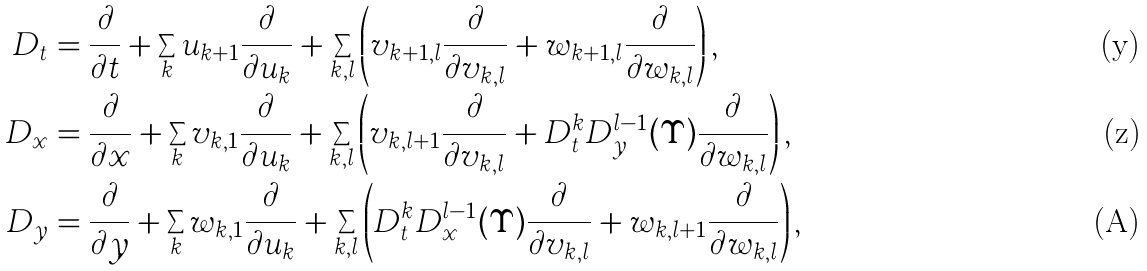Convert formula to latex. <formula><loc_0><loc_0><loc_500><loc_500>D _ { t } & = \frac { \partial } { \partial t } + \sum _ { k } u _ { k + 1 } \frac { \partial } { \partial u _ { k } } + \sum _ { k , l } \left ( v _ { k + 1 , l } \frac { \partial } { \partial v _ { k , l } } + w _ { k + 1 , l } \frac { \partial } { \partial w _ { k , l } } \right ) , \\ D _ { x } & = \frac { \partial } { \partial x } + \sum _ { k } v _ { k , 1 } \frac { \partial } { \partial u _ { k } } + \sum _ { k , l } \left ( v _ { k , l + 1 } \frac { \partial } { \partial v _ { k , l } } + D _ { t } ^ { k } D _ { y } ^ { l - 1 } ( \Upsilon ) \frac { \partial } { \partial w _ { k , l } } \right ) , \\ D _ { y } & = \frac { \partial } { \partial y } + \sum _ { k } w _ { k , 1 } \frac { \partial } { \partial u _ { k } } + \sum _ { k , l } \left ( D _ { t } ^ { k } D _ { x } ^ { l - 1 } ( \Upsilon ) \frac { \partial } { \partial v _ { k , l } } + w _ { k , l + 1 } \frac { \partial } { \partial w _ { k , l } } \right ) ,</formula> 